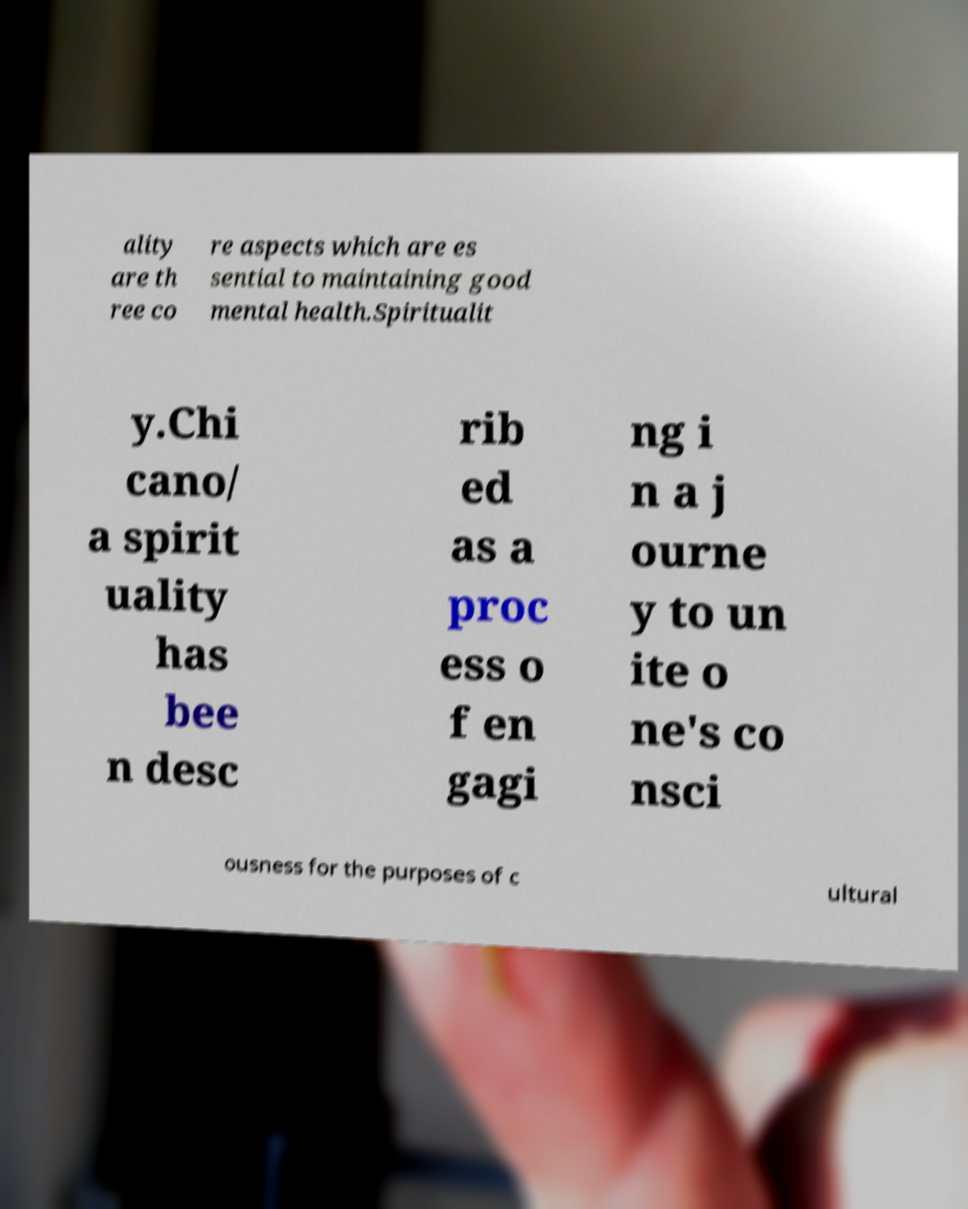Please read and relay the text visible in this image. What does it say? ality are th ree co re aspects which are es sential to maintaining good mental health.Spiritualit y.Chi cano/ a spirit uality has bee n desc rib ed as a proc ess o f en gagi ng i n a j ourne y to un ite o ne's co nsci ousness for the purposes of c ultural 